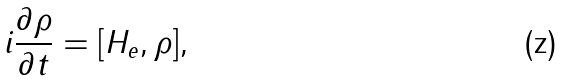Convert formula to latex. <formula><loc_0><loc_0><loc_500><loc_500>i \frac { \partial \rho } { \partial t } = [ H _ { e } , \rho ] ,</formula> 